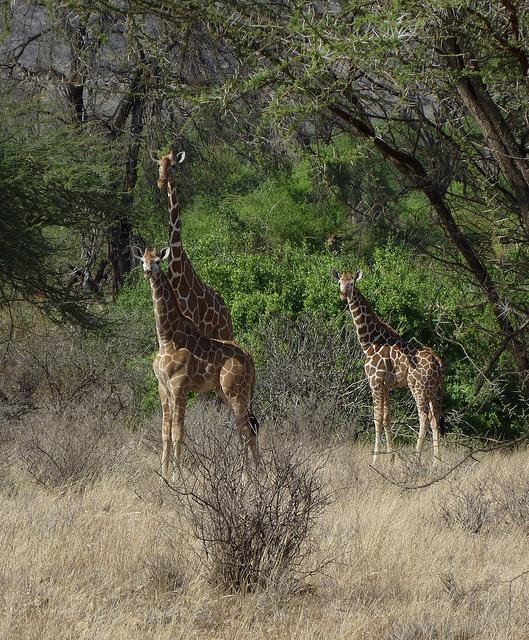How many giraffes are there?
Give a very brief answer. 3. How many giraffes are in the picture?
Give a very brief answer. 3. How many people in the background wears in yellow?
Give a very brief answer. 0. 